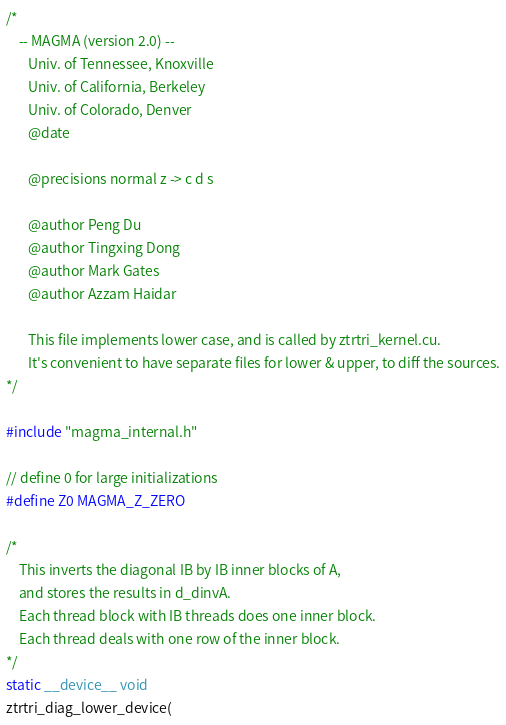Convert code to text. <code><loc_0><loc_0><loc_500><loc_500><_Cuda_>/*
    -- MAGMA (version 2.0) --
       Univ. of Tennessee, Knoxville
       Univ. of California, Berkeley
       Univ. of Colorado, Denver
       @date

       @precisions normal z -> c d s

       @author Peng Du
       @author Tingxing Dong
       @author Mark Gates
       @author Azzam Haidar
       
       This file implements lower case, and is called by ztrtri_kernel.cu.
       It's convenient to have separate files for lower & upper, to diff the sources.
*/

#include "magma_internal.h"

// define 0 for large initializations
#define Z0 MAGMA_Z_ZERO

/*
    This inverts the diagonal IB by IB inner blocks of A,
    and stores the results in d_dinvA.
    Each thread block with IB threads does one inner block.
    Each thread deals with one row of the inner block.
*/
static __device__ void
ztrtri_diag_lower_device(</code> 